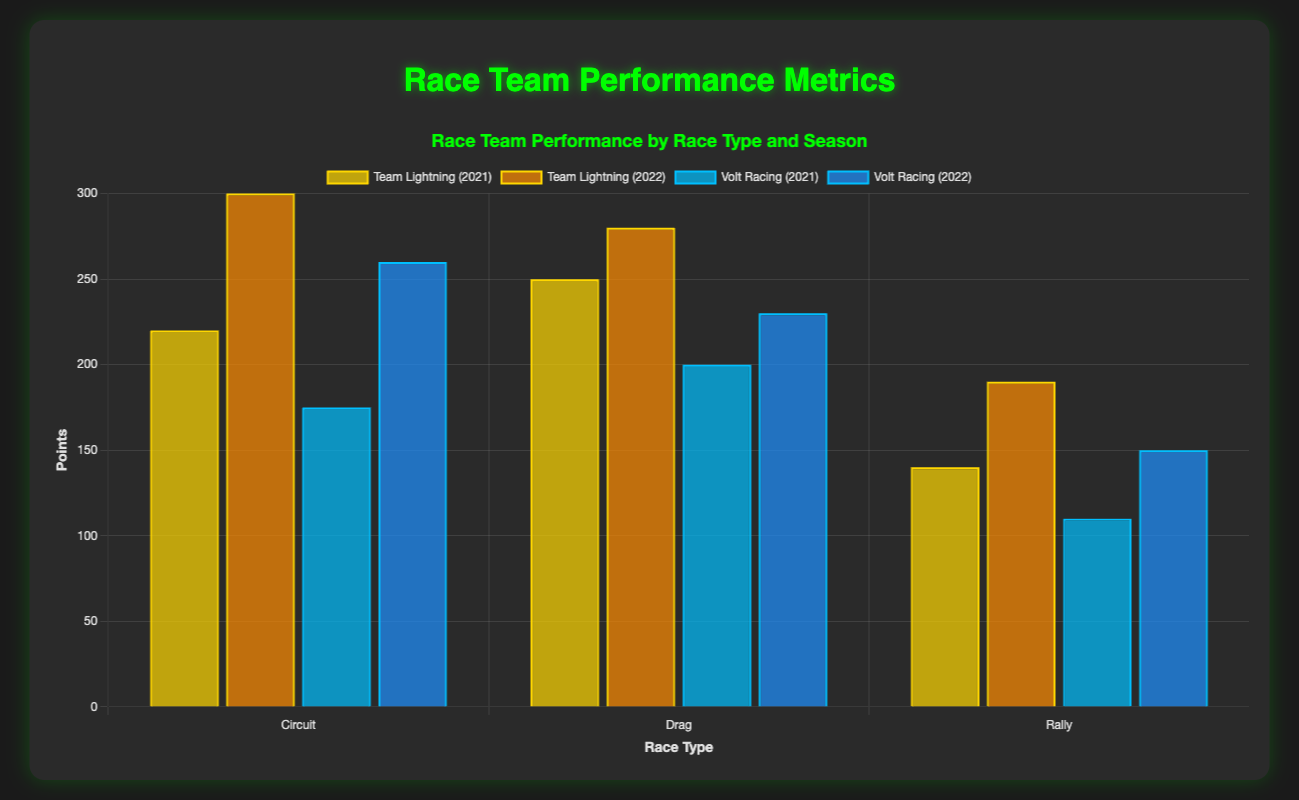Which team had the highest points in the 2022 season for Circuit races? To find the answer, look at the grouped bars for "Circuit" in the year 2022 and compare the heights of the bars labeled for "Team Lightning" and "Volt Racing." "Team Lightning" has 300 points and "Volt Racing" has 260 points. Therefore, "Team Lightning" had the highest points.
Answer: Team Lightning How many total wins did Volt Racing have across all race types in the 2022 season? First, identify the wins for Volt Racing in 2022 for each race type: Circuit (3 wins), Drag (4 wins), and Rally (2 wins). Sum these values: 3 + 4 + 2 = 9. Volt Racing had 9 wins in total.
Answer: 9 Which team had fewer mechanical failures in the 2021 Drag races? Look at the grouped bars for "Drag" in the year 2021 and compare the heights of the bars labeled for "Team Lightning" and "Volt Racing" regarding mechanical failures. "Team Lightning" has 0 mechanical failures, whereas "Volt Racing" has 1. So, "Team Lightning" had fewer mechanical failures.
Answer: Team Lightning What's the total number of points accumulated by Team Lightning in the 2021 season for all race types? Identify the points for Team Lightning in 2021 for each race type: Circuit (220 points), Drag (250 points), and Rally (140 points). Sum these values: 220 + 250 + 140 = 610. Team Lightning had a total of 610 points.
Answer: 610 Compare the number of wins between Team Lightning and Volt Racing in Rally races for the 2022 season and identify which has more. Look at the wins for both teams in Rally races for the 2022 season: Team Lightning has 3 wins, whereas Volt Racing has 2 wins. Therefore, Team Lightning has more wins.
Answer: Team Lightning In which season did Volt Racing perform better in terms of total points for Circuit races? Compare the total points for Volt Racing in Circuit races across both seasons: 2021 (175 points) and 2022 (260 points). Volt Racing performed better in the 2022 season.
Answer: 2022 How did the podium finishes of Team Lightning differ between the 2021 and 2022 seasons in Drag races? Compare the podiums for Team Lightning in Drag races between 2021 and 2022: 2021 had 7 podiums and 2022 had 8 podiums. The difference is 8 - 7 = 1 more podium in the 2022 season.
Answer: 1 more podium in 2022 Which team had the same number of fastest laps in Circuit races across both 2021 and 2022 seasons? Identify the number of fastest laps in Circuit races for both teams: Team Lightning has 5 in 2021 and 6 in 2022, whereas Volt Racing has 3 in 2021 and 4 in 2022. No team has the same number of fastest laps across both seasons.
Answer: Neither team What are the colors of the bars representing Team Lightning and Volt Racing in the 2021 season for Circuit races? For the Circuit races in the 2021 season, the bars for Team Lightning are gold and the bars for Volt Racing are blue.
Answer: Gold and blue 